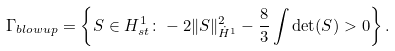<formula> <loc_0><loc_0><loc_500><loc_500>\Gamma _ { b l o w u p } = \left \{ S \in H ^ { 1 } _ { s t } \colon - 2 \| S \| _ { \dot { H } ^ { 1 } } ^ { 2 } - \frac { 8 } { 3 } \int \det ( S ) > 0 \right \} .</formula> 